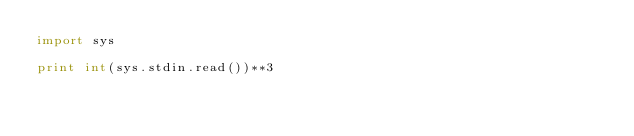Convert code to text. <code><loc_0><loc_0><loc_500><loc_500><_Python_>import sys

print int(sys.stdin.read())**3
</code> 